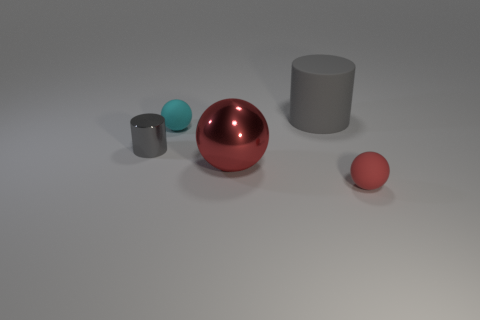Could you describe the scene's lighting and shadow direction? The scene is lightly lit from above, casting subtle shadows directly beneath the objects, indicating the light source is positioned roughly in the middle of the scene, possibly a bit towards the front. The lighting suggests an indoor setting with a controlled light source. 